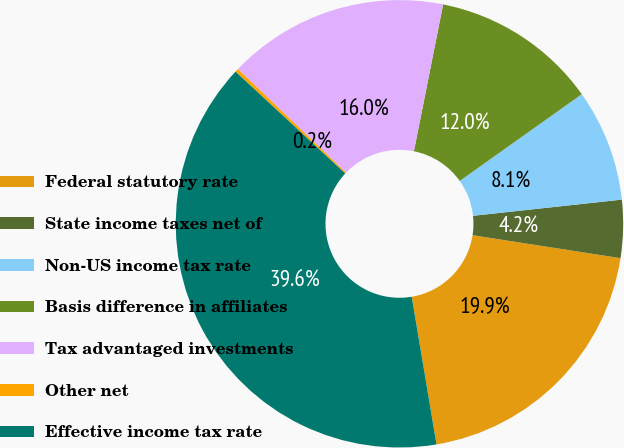<chart> <loc_0><loc_0><loc_500><loc_500><pie_chart><fcel>Federal statutory rate<fcel>State income taxes net of<fcel>Non-US income tax rate<fcel>Basis difference in affiliates<fcel>Tax advantaged investments<fcel>Other net<fcel>Effective income tax rate<nl><fcel>19.9%<fcel>4.18%<fcel>8.11%<fcel>12.04%<fcel>15.97%<fcel>0.25%<fcel>39.56%<nl></chart> 